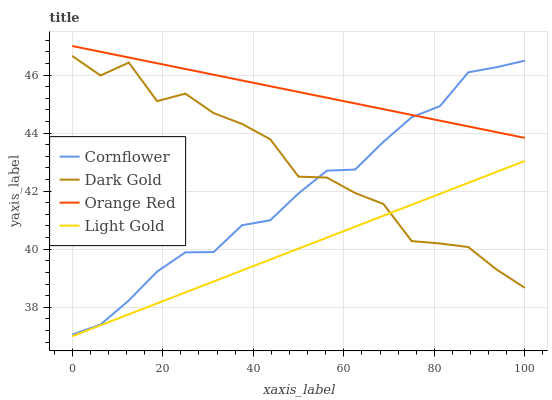Does Orange Red have the minimum area under the curve?
Answer yes or no. No. Does Light Gold have the maximum area under the curve?
Answer yes or no. No. Is Dark Gold the smoothest?
Answer yes or no. No. Is Orange Red the roughest?
Answer yes or no. No. Does Orange Red have the lowest value?
Answer yes or no. No. Does Light Gold have the highest value?
Answer yes or no. No. Is Dark Gold less than Orange Red?
Answer yes or no. Yes. Is Cornflower greater than Light Gold?
Answer yes or no. Yes. Does Dark Gold intersect Orange Red?
Answer yes or no. No. 